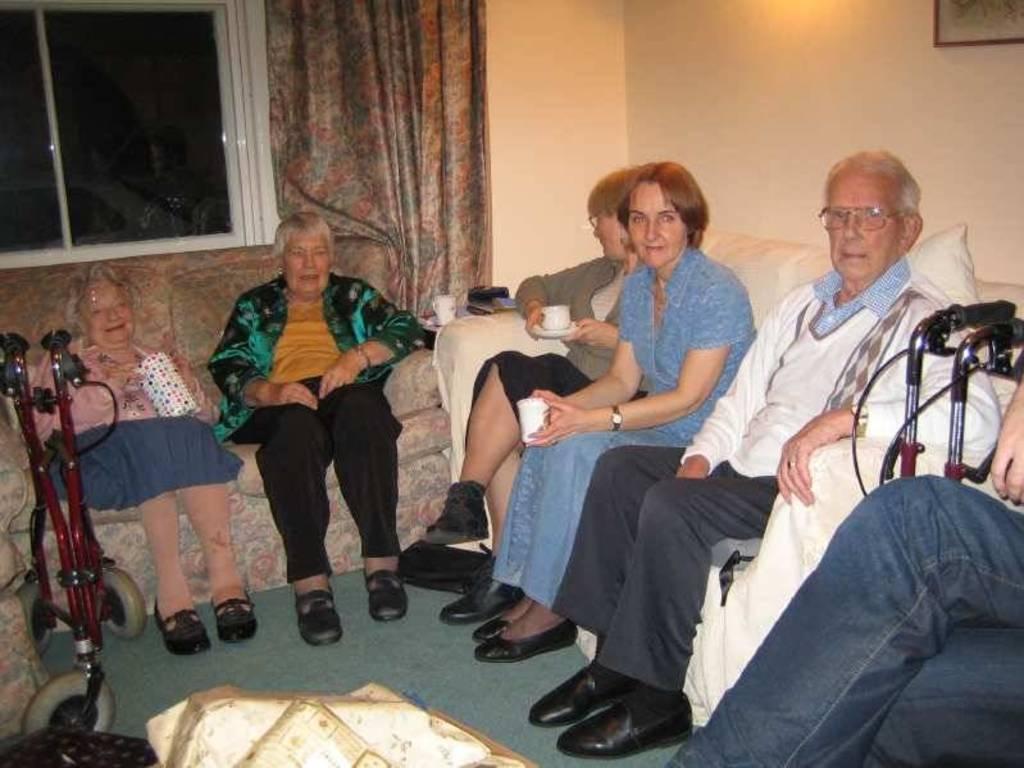Could you give a brief overview of what you see in this image? In this image I can see number of persons are sitting on couches which are white and cream in color. I can see all of them are wearing footwear. In the background I can see the cream colored wall, a photo frame attached to the wall, the curtain and the window. 